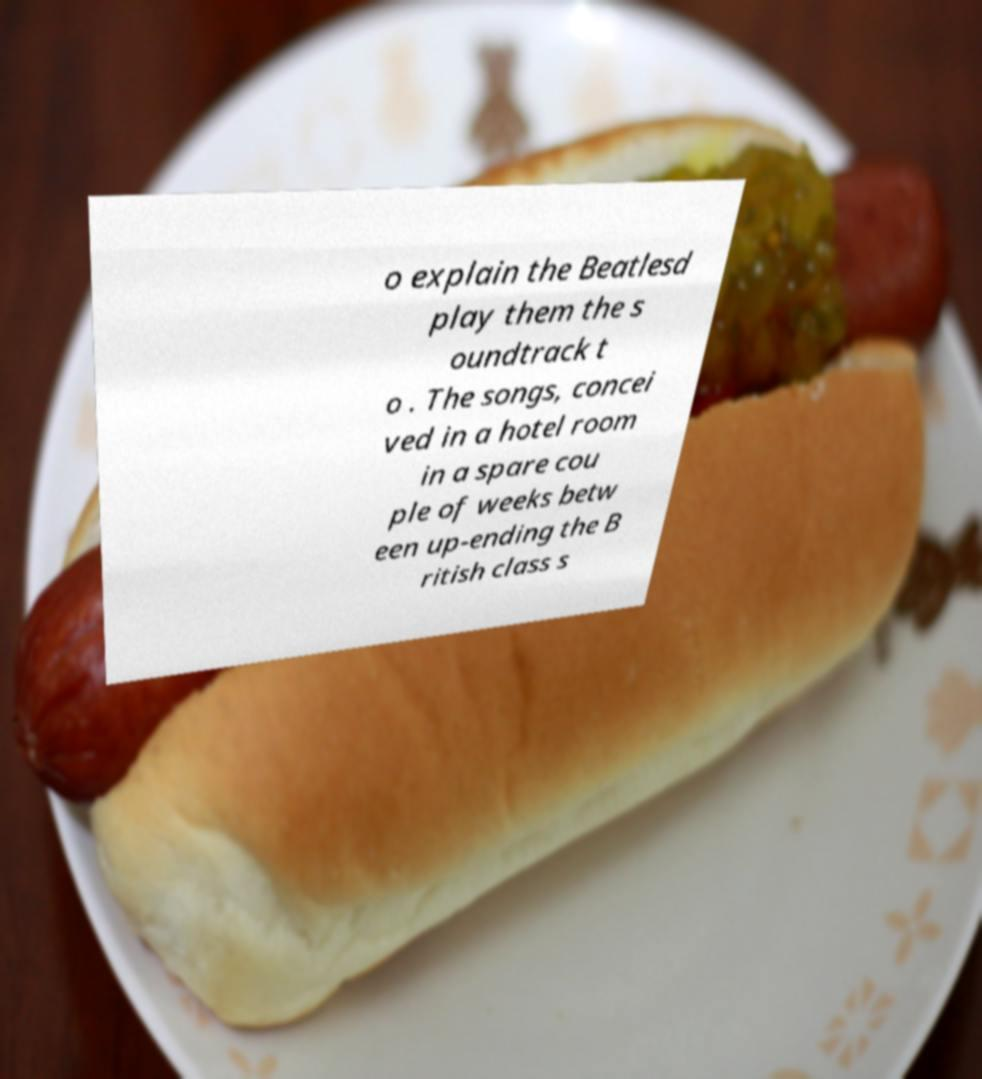Please identify and transcribe the text found in this image. o explain the Beatlesd play them the s oundtrack t o . The songs, concei ved in a hotel room in a spare cou ple of weeks betw een up-ending the B ritish class s 